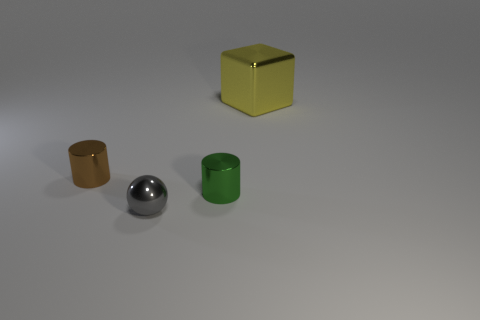Add 4 tiny brown shiny cylinders. How many objects exist? 8 Subtract all balls. How many objects are left? 3 Subtract all big red objects. Subtract all gray objects. How many objects are left? 3 Add 1 large cubes. How many large cubes are left? 2 Add 2 gray spheres. How many gray spheres exist? 3 Subtract 1 gray spheres. How many objects are left? 3 